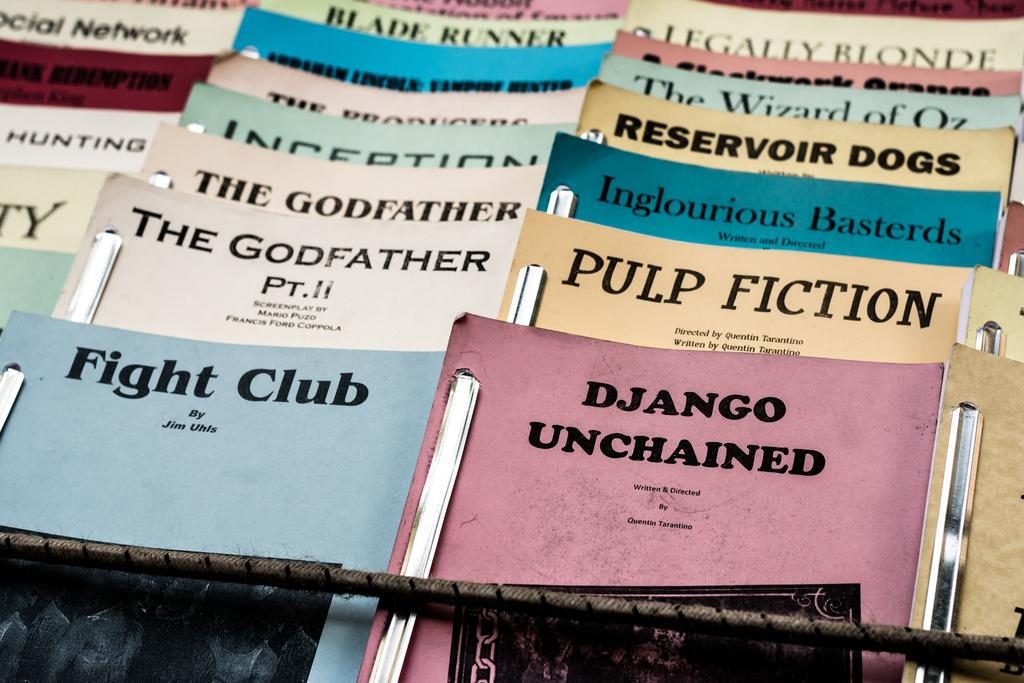<image>
Offer a succinct explanation of the picture presented. Many pamphlets including one that says Pulp Fiction. 